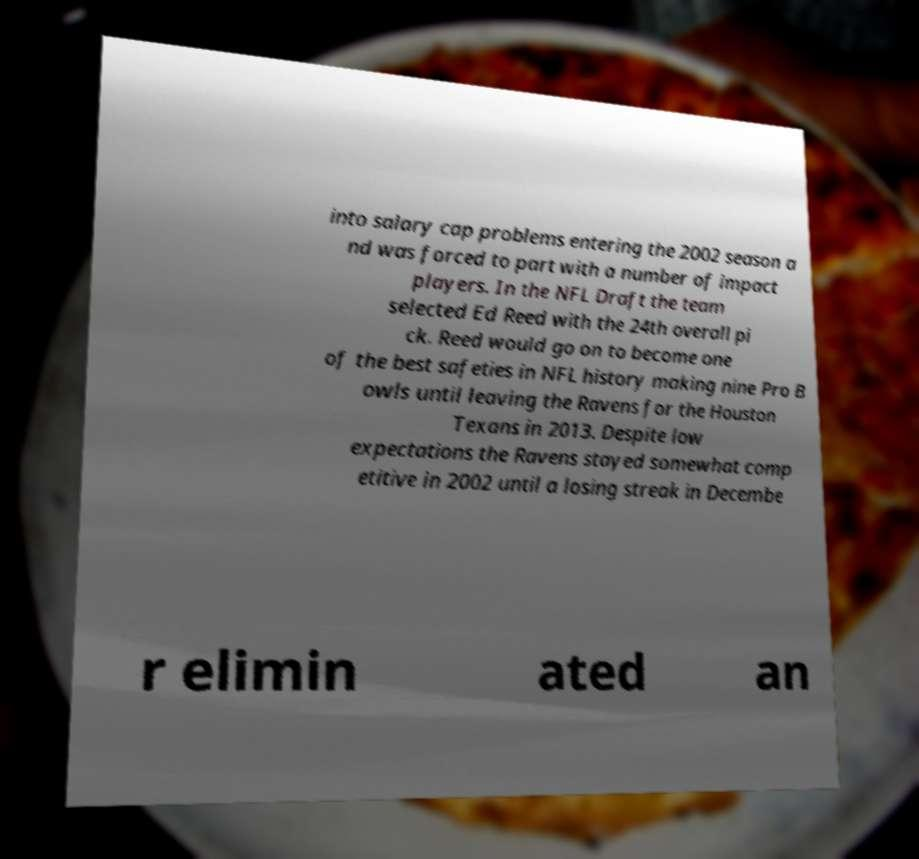What messages or text are displayed in this image? I need them in a readable, typed format. into salary cap problems entering the 2002 season a nd was forced to part with a number of impact players. In the NFL Draft the team selected Ed Reed with the 24th overall pi ck. Reed would go on to become one of the best safeties in NFL history making nine Pro B owls until leaving the Ravens for the Houston Texans in 2013. Despite low expectations the Ravens stayed somewhat comp etitive in 2002 until a losing streak in Decembe r elimin ated an 